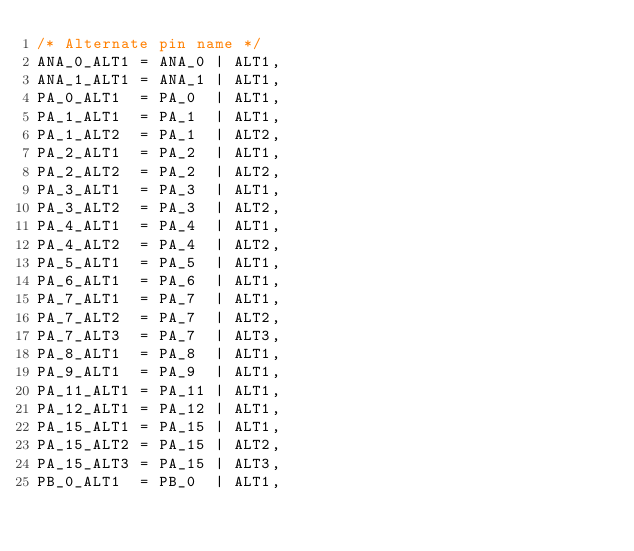<code> <loc_0><loc_0><loc_500><loc_500><_C_>/* Alternate pin name */
ANA_0_ALT1 = ANA_0 | ALT1,
ANA_1_ALT1 = ANA_1 | ALT1,
PA_0_ALT1  = PA_0  | ALT1,
PA_1_ALT1  = PA_1  | ALT1,
PA_1_ALT2  = PA_1  | ALT2,
PA_2_ALT1  = PA_2  | ALT1,
PA_2_ALT2  = PA_2  | ALT2,
PA_3_ALT1  = PA_3  | ALT1,
PA_3_ALT2  = PA_3  | ALT2,
PA_4_ALT1  = PA_4  | ALT1,
PA_4_ALT2  = PA_4  | ALT2,
PA_5_ALT1  = PA_5  | ALT1,
PA_6_ALT1  = PA_6  | ALT1,
PA_7_ALT1  = PA_7  | ALT1,
PA_7_ALT2  = PA_7  | ALT2,
PA_7_ALT3  = PA_7  | ALT3,
PA_8_ALT1  = PA_8  | ALT1,
PA_9_ALT1  = PA_9  | ALT1,
PA_11_ALT1 = PA_11 | ALT1,
PA_12_ALT1 = PA_12 | ALT1,
PA_15_ALT1 = PA_15 | ALT1,
PA_15_ALT2 = PA_15 | ALT2,
PA_15_ALT3 = PA_15 | ALT3,
PB_0_ALT1  = PB_0  | ALT1,</code> 